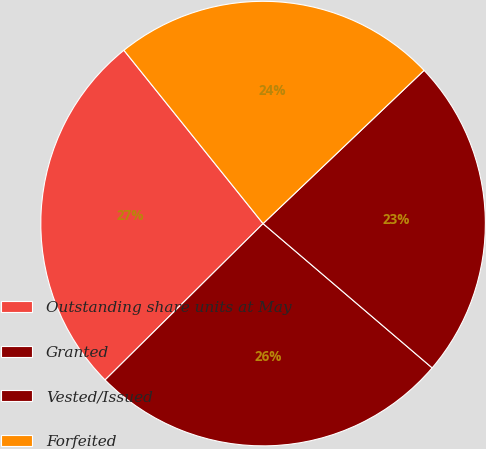<chart> <loc_0><loc_0><loc_500><loc_500><pie_chart><fcel>Outstanding share units at May<fcel>Granted<fcel>Vested/Issued<fcel>Forfeited<nl><fcel>26.65%<fcel>26.34%<fcel>23.35%<fcel>23.66%<nl></chart> 